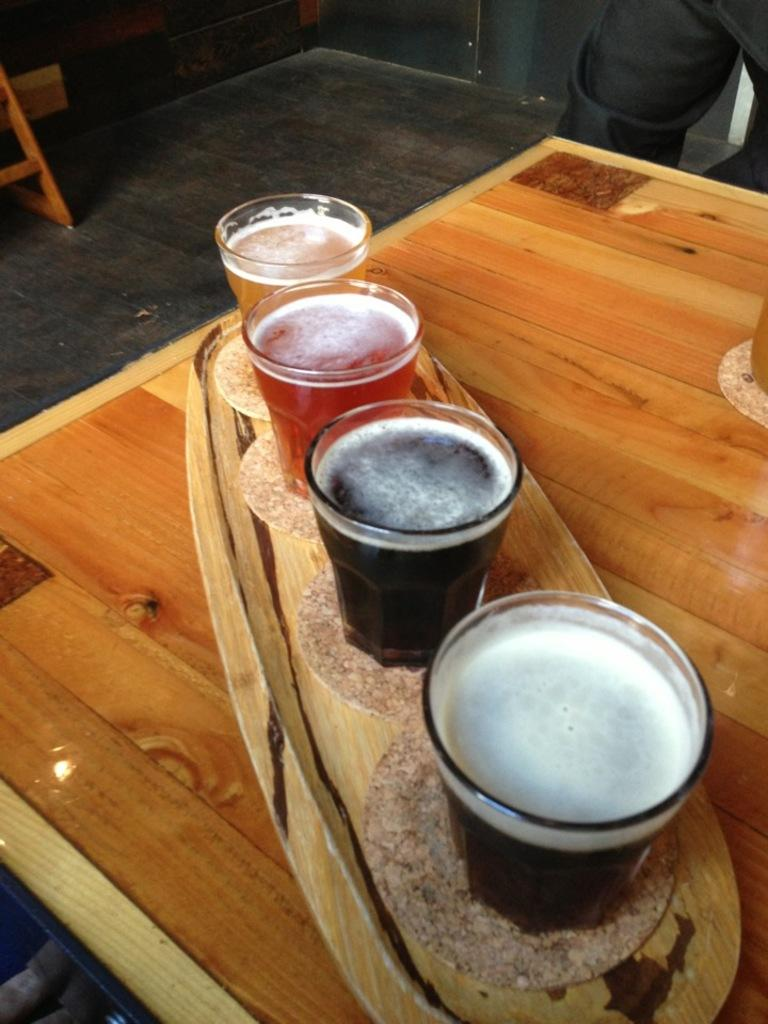What is placed on the platter in the image? There are drinks placed on a platter in the image. Where is the platter located? The platter is on a table. What can be seen on the left side of the image? There is a wooden object on the left side of the image. Can you describe the person on the right side of the image? There is a person on the right side of the image. What type of fish is swimming in the drinks on the platter? There are no fish present in the image, and the drinks are not depicted as containing any fish. 